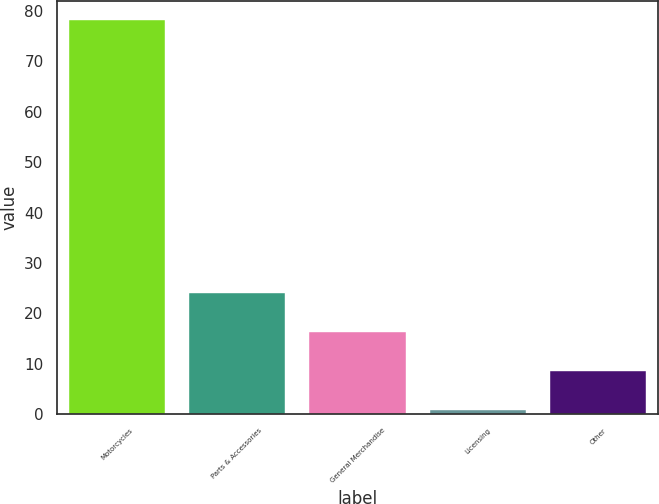Convert chart to OTSL. <chart><loc_0><loc_0><loc_500><loc_500><bar_chart><fcel>Motorcycles<fcel>Parts & Accessories<fcel>General Merchandise<fcel>Licensing<fcel>Other<nl><fcel>78.1<fcel>23.99<fcel>16.26<fcel>0.8<fcel>8.53<nl></chart> 